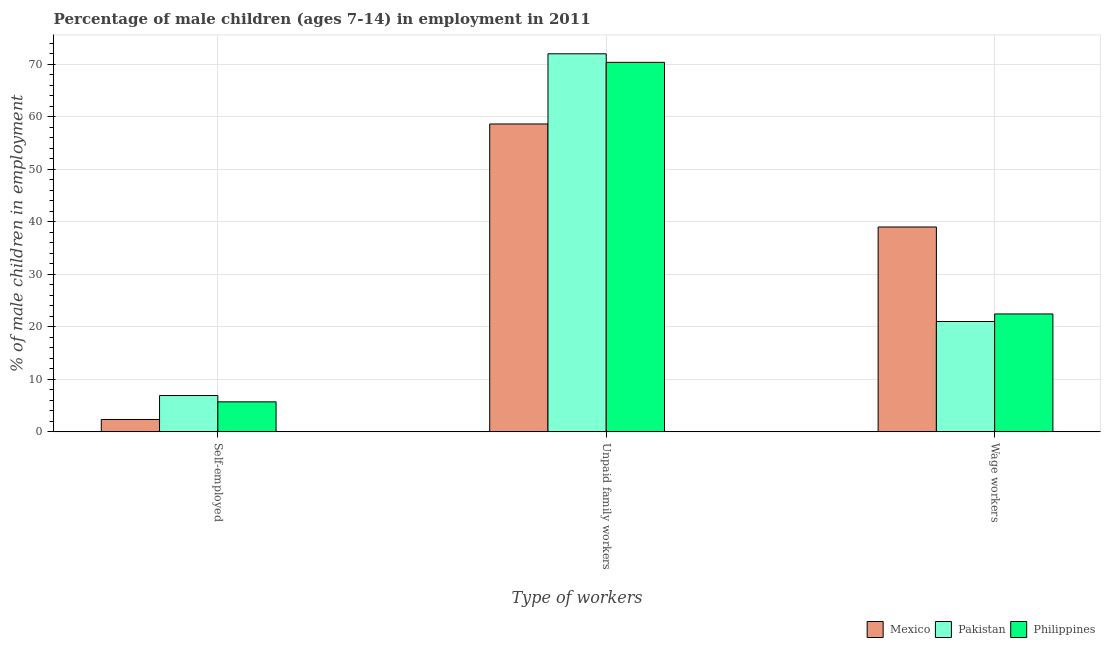Are the number of bars on each tick of the X-axis equal?
Offer a terse response. Yes. How many bars are there on the 3rd tick from the right?
Your response must be concise. 3. What is the label of the 2nd group of bars from the left?
Provide a succinct answer. Unpaid family workers. What is the percentage of children employed as unpaid family workers in Pakistan?
Offer a terse response. 71.98. Across all countries, what is the maximum percentage of children employed as unpaid family workers?
Provide a short and direct response. 71.98. Across all countries, what is the minimum percentage of self employed children?
Ensure brevity in your answer.  2.37. In which country was the percentage of children employed as wage workers maximum?
Offer a very short reply. Mexico. What is the total percentage of children employed as wage workers in the graph?
Make the answer very short. 82.49. What is the difference between the percentage of children employed as unpaid family workers in Pakistan and that in Mexico?
Your answer should be very brief. 13.36. What is the difference between the percentage of children employed as unpaid family workers in Mexico and the percentage of self employed children in Philippines?
Give a very brief answer. 52.89. What is the average percentage of children employed as wage workers per country?
Ensure brevity in your answer.  27.5. What is the difference between the percentage of children employed as wage workers and percentage of self employed children in Mexico?
Offer a terse response. 36.64. What is the ratio of the percentage of self employed children in Philippines to that in Pakistan?
Provide a succinct answer. 0.83. Is the difference between the percentage of children employed as wage workers in Mexico and Philippines greater than the difference between the percentage of self employed children in Mexico and Philippines?
Offer a terse response. Yes. What is the difference between the highest and the second highest percentage of children employed as unpaid family workers?
Keep it short and to the point. 1.63. What is the difference between the highest and the lowest percentage of children employed as unpaid family workers?
Ensure brevity in your answer.  13.36. Is the sum of the percentage of children employed as unpaid family workers in Mexico and Pakistan greater than the maximum percentage of children employed as wage workers across all countries?
Your response must be concise. Yes. What does the 1st bar from the right in Unpaid family workers represents?
Ensure brevity in your answer.  Philippines. Is it the case that in every country, the sum of the percentage of self employed children and percentage of children employed as unpaid family workers is greater than the percentage of children employed as wage workers?
Your answer should be very brief. Yes. How many bars are there?
Ensure brevity in your answer.  9. How many countries are there in the graph?
Your answer should be very brief. 3. Are the values on the major ticks of Y-axis written in scientific E-notation?
Offer a terse response. No. Does the graph contain any zero values?
Give a very brief answer. No. Does the graph contain grids?
Make the answer very short. Yes. How many legend labels are there?
Provide a short and direct response. 3. What is the title of the graph?
Your answer should be very brief. Percentage of male children (ages 7-14) in employment in 2011. Does "Small states" appear as one of the legend labels in the graph?
Give a very brief answer. No. What is the label or title of the X-axis?
Offer a very short reply. Type of workers. What is the label or title of the Y-axis?
Give a very brief answer. % of male children in employment. What is the % of male children in employment of Mexico in Self-employed?
Ensure brevity in your answer.  2.37. What is the % of male children in employment in Pakistan in Self-employed?
Provide a short and direct response. 6.93. What is the % of male children in employment in Philippines in Self-employed?
Offer a terse response. 5.73. What is the % of male children in employment in Mexico in Unpaid family workers?
Ensure brevity in your answer.  58.62. What is the % of male children in employment in Pakistan in Unpaid family workers?
Provide a short and direct response. 71.98. What is the % of male children in employment in Philippines in Unpaid family workers?
Your answer should be compact. 70.35. What is the % of male children in employment in Mexico in Wage workers?
Ensure brevity in your answer.  39.01. What is the % of male children in employment in Pakistan in Wage workers?
Your answer should be very brief. 21.02. What is the % of male children in employment in Philippines in Wage workers?
Ensure brevity in your answer.  22.46. Across all Type of workers, what is the maximum % of male children in employment of Mexico?
Your answer should be very brief. 58.62. Across all Type of workers, what is the maximum % of male children in employment of Pakistan?
Your answer should be very brief. 71.98. Across all Type of workers, what is the maximum % of male children in employment of Philippines?
Your answer should be very brief. 70.35. Across all Type of workers, what is the minimum % of male children in employment in Mexico?
Make the answer very short. 2.37. Across all Type of workers, what is the minimum % of male children in employment of Pakistan?
Your response must be concise. 6.93. Across all Type of workers, what is the minimum % of male children in employment of Philippines?
Your answer should be very brief. 5.73. What is the total % of male children in employment in Pakistan in the graph?
Provide a succinct answer. 99.93. What is the total % of male children in employment of Philippines in the graph?
Your response must be concise. 98.54. What is the difference between the % of male children in employment of Mexico in Self-employed and that in Unpaid family workers?
Ensure brevity in your answer.  -56.25. What is the difference between the % of male children in employment in Pakistan in Self-employed and that in Unpaid family workers?
Your answer should be compact. -65.05. What is the difference between the % of male children in employment of Philippines in Self-employed and that in Unpaid family workers?
Your answer should be compact. -64.62. What is the difference between the % of male children in employment in Mexico in Self-employed and that in Wage workers?
Provide a short and direct response. -36.64. What is the difference between the % of male children in employment of Pakistan in Self-employed and that in Wage workers?
Your answer should be very brief. -14.09. What is the difference between the % of male children in employment of Philippines in Self-employed and that in Wage workers?
Give a very brief answer. -16.73. What is the difference between the % of male children in employment in Mexico in Unpaid family workers and that in Wage workers?
Your answer should be compact. 19.61. What is the difference between the % of male children in employment in Pakistan in Unpaid family workers and that in Wage workers?
Provide a succinct answer. 50.96. What is the difference between the % of male children in employment in Philippines in Unpaid family workers and that in Wage workers?
Ensure brevity in your answer.  47.89. What is the difference between the % of male children in employment of Mexico in Self-employed and the % of male children in employment of Pakistan in Unpaid family workers?
Keep it short and to the point. -69.61. What is the difference between the % of male children in employment in Mexico in Self-employed and the % of male children in employment in Philippines in Unpaid family workers?
Your response must be concise. -67.98. What is the difference between the % of male children in employment of Pakistan in Self-employed and the % of male children in employment of Philippines in Unpaid family workers?
Make the answer very short. -63.42. What is the difference between the % of male children in employment in Mexico in Self-employed and the % of male children in employment in Pakistan in Wage workers?
Offer a terse response. -18.65. What is the difference between the % of male children in employment in Mexico in Self-employed and the % of male children in employment in Philippines in Wage workers?
Provide a short and direct response. -20.09. What is the difference between the % of male children in employment of Pakistan in Self-employed and the % of male children in employment of Philippines in Wage workers?
Your answer should be compact. -15.53. What is the difference between the % of male children in employment in Mexico in Unpaid family workers and the % of male children in employment in Pakistan in Wage workers?
Provide a short and direct response. 37.6. What is the difference between the % of male children in employment in Mexico in Unpaid family workers and the % of male children in employment in Philippines in Wage workers?
Your answer should be very brief. 36.16. What is the difference between the % of male children in employment in Pakistan in Unpaid family workers and the % of male children in employment in Philippines in Wage workers?
Ensure brevity in your answer.  49.52. What is the average % of male children in employment in Mexico per Type of workers?
Give a very brief answer. 33.33. What is the average % of male children in employment in Pakistan per Type of workers?
Offer a very short reply. 33.31. What is the average % of male children in employment of Philippines per Type of workers?
Your answer should be very brief. 32.85. What is the difference between the % of male children in employment in Mexico and % of male children in employment in Pakistan in Self-employed?
Your answer should be very brief. -4.56. What is the difference between the % of male children in employment in Mexico and % of male children in employment in Philippines in Self-employed?
Provide a short and direct response. -3.36. What is the difference between the % of male children in employment in Pakistan and % of male children in employment in Philippines in Self-employed?
Ensure brevity in your answer.  1.2. What is the difference between the % of male children in employment in Mexico and % of male children in employment in Pakistan in Unpaid family workers?
Provide a short and direct response. -13.36. What is the difference between the % of male children in employment of Mexico and % of male children in employment of Philippines in Unpaid family workers?
Give a very brief answer. -11.73. What is the difference between the % of male children in employment in Pakistan and % of male children in employment in Philippines in Unpaid family workers?
Your answer should be compact. 1.63. What is the difference between the % of male children in employment in Mexico and % of male children in employment in Pakistan in Wage workers?
Keep it short and to the point. 17.99. What is the difference between the % of male children in employment of Mexico and % of male children in employment of Philippines in Wage workers?
Offer a terse response. 16.55. What is the difference between the % of male children in employment of Pakistan and % of male children in employment of Philippines in Wage workers?
Ensure brevity in your answer.  -1.44. What is the ratio of the % of male children in employment in Mexico in Self-employed to that in Unpaid family workers?
Your response must be concise. 0.04. What is the ratio of the % of male children in employment in Pakistan in Self-employed to that in Unpaid family workers?
Your answer should be compact. 0.1. What is the ratio of the % of male children in employment in Philippines in Self-employed to that in Unpaid family workers?
Offer a terse response. 0.08. What is the ratio of the % of male children in employment of Mexico in Self-employed to that in Wage workers?
Provide a succinct answer. 0.06. What is the ratio of the % of male children in employment in Pakistan in Self-employed to that in Wage workers?
Your response must be concise. 0.33. What is the ratio of the % of male children in employment in Philippines in Self-employed to that in Wage workers?
Give a very brief answer. 0.26. What is the ratio of the % of male children in employment in Mexico in Unpaid family workers to that in Wage workers?
Your response must be concise. 1.5. What is the ratio of the % of male children in employment in Pakistan in Unpaid family workers to that in Wage workers?
Provide a short and direct response. 3.42. What is the ratio of the % of male children in employment of Philippines in Unpaid family workers to that in Wage workers?
Keep it short and to the point. 3.13. What is the difference between the highest and the second highest % of male children in employment in Mexico?
Provide a short and direct response. 19.61. What is the difference between the highest and the second highest % of male children in employment in Pakistan?
Ensure brevity in your answer.  50.96. What is the difference between the highest and the second highest % of male children in employment in Philippines?
Offer a terse response. 47.89. What is the difference between the highest and the lowest % of male children in employment of Mexico?
Make the answer very short. 56.25. What is the difference between the highest and the lowest % of male children in employment in Pakistan?
Your answer should be very brief. 65.05. What is the difference between the highest and the lowest % of male children in employment in Philippines?
Provide a succinct answer. 64.62. 